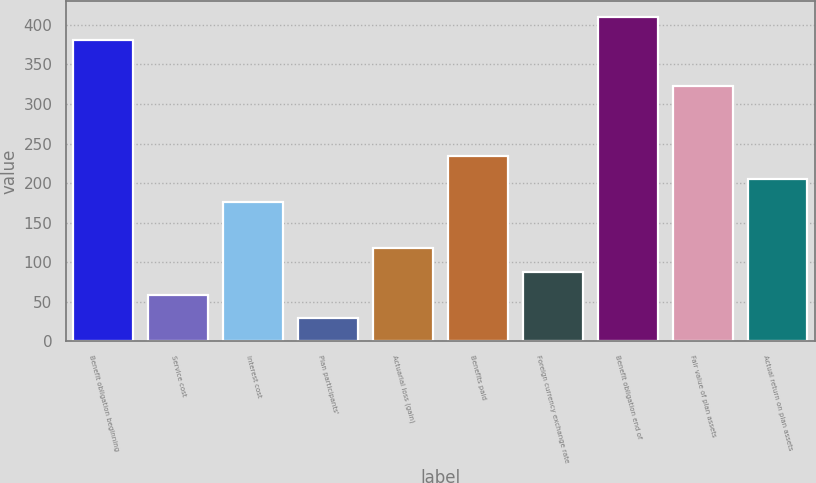<chart> <loc_0><loc_0><loc_500><loc_500><bar_chart><fcel>Benefit obligation beginning<fcel>Service cost<fcel>Interest cost<fcel>Plan participants'<fcel>Actuarial loss (gain)<fcel>Benefits paid<fcel>Foreign currency exchange rate<fcel>Benefit obligation end of<fcel>Fair value of plan assets<fcel>Actual return on plan assets<nl><fcel>380.78<fcel>58.92<fcel>175.96<fcel>29.66<fcel>117.44<fcel>234.48<fcel>88.18<fcel>410.04<fcel>322.26<fcel>205.22<nl></chart> 